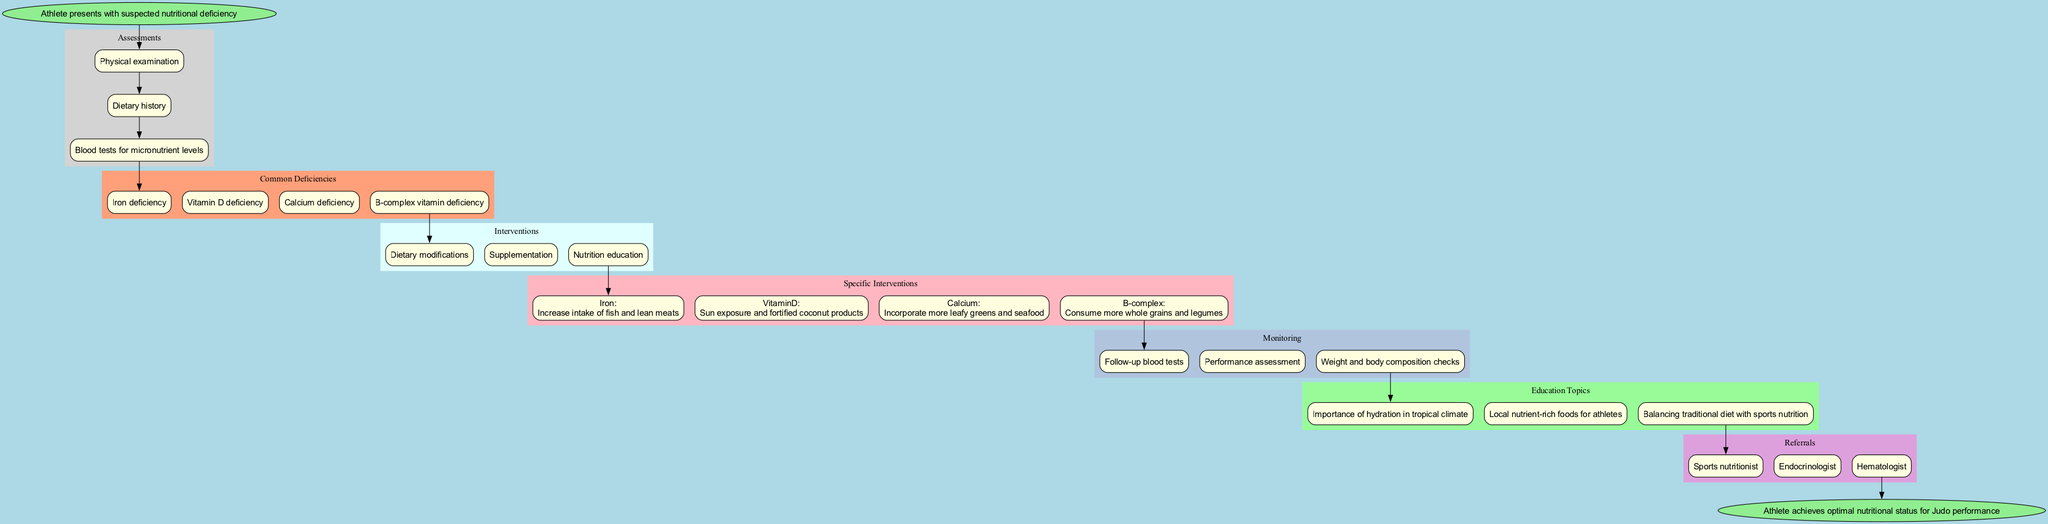What is the starting point of the pathway? The starting point of the pathway is labeled as "Athlete presents with suspected nutritional deficiency". This node indicates where the process begins.
Answer: Athlete presents with suspected nutritional deficiency How many common nutritional deficiencies are identified? The diagram lists four common deficiencies: Iron deficiency, Vitamin D deficiency, Calcium deficiency, and B-complex vitamin deficiency. Thus, by counting these deficiencies, we arrive at the total.
Answer: 4 What intervention follows after identifying a deficiency? After identifying the deficiency, the next step in the pathway involves interventions. The interventions listed include "Dietary modifications", "Supplementation", and "Nutrition education". The first of these interventions directly follows the deficiencies.
Answer: Dietary modifications Which specific intervention is suggested for Vitamin D deficiency? The specific intervention for Vitamin D deficiency is "Sun exposure and fortified coconut products". This is derived from the section on specific interventions for each common deficiency.
Answer: Sun exposure and fortified coconut products What is the last step in the clinical pathway? The pathway culminates in the endpoint node labeled "Athlete achieves optimal nutritional status for Judo performance". This node indicates the ultimate goal of the pathway.
Answer: Athlete achieves optimal nutritional status for Judo performance Which two types of specialists does the pathway refer to for further assistance? The pathway includes referrals to a "Sports nutritionist" and an "Endocrinologist". By reviewing the referrals section, we can identify these two types of specialists explicitly mentioned.
Answer: Sports nutritionist, Endocrinologist How is the athlete's performance assessed after nutritional interventions? The athlete's performance is assessed through "Performance assessment". This helps to determine the effectiveness of the implemented nutritional interventions.
Answer: Performance assessment What is one educational topic covered in the pathway? One educational topic covered is "Importance of hydration in tropical climate". This is listed in the education topics section of the diagram, highlighting a crucial aspect of athlete nutrition.
Answer: Importance of hydration in tropical climate 